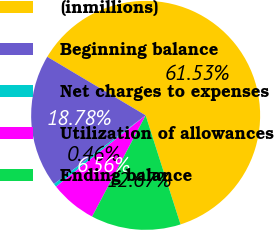Convert chart. <chart><loc_0><loc_0><loc_500><loc_500><pie_chart><fcel>(inmillions)<fcel>Beginning balance<fcel>Net charges to expenses<fcel>Utilization of allowances<fcel>Ending balance<nl><fcel>61.53%<fcel>18.78%<fcel>0.46%<fcel>6.56%<fcel>12.67%<nl></chart> 